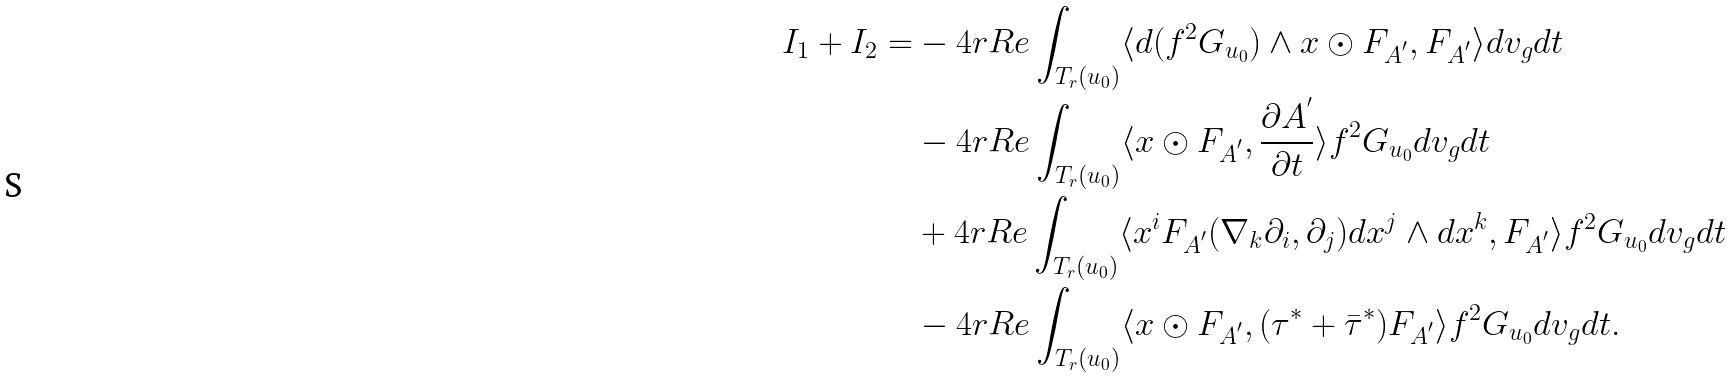<formula> <loc_0><loc_0><loc_500><loc_500>I _ { 1 } + I _ { 2 } = & - 4 r R e \int _ { T _ { r } ( u _ { 0 } ) } \langle d ( f ^ { 2 } G _ { u _ { 0 } } ) \wedge x \odot F _ { A ^ { ^ { \prime } } } , F _ { A ^ { ^ { \prime } } } \rangle d v _ { g } d t \\ & - 4 r R e \int _ { T _ { r } ( u _ { 0 } ) } \langle x \odot F _ { A ^ { ^ { \prime } } } , \frac { \partial A ^ { ^ { \prime } } } { \partial t } \rangle f ^ { 2 } G _ { u _ { 0 } } d v _ { g } d t \\ & + 4 r R e \int _ { T _ { r } ( u _ { 0 } ) } \langle x ^ { i } F _ { A ^ { ^ { \prime } } } ( \nabla _ { k } \partial _ { i } , \partial _ { j } ) d x ^ { j } \wedge d x ^ { k } , F _ { A ^ { ^ { \prime } } } \rangle f ^ { 2 } G _ { u _ { 0 } } d v _ { g } d t \\ & - 4 r R e \int _ { T _ { r } ( u _ { 0 } ) } \langle x \odot F _ { A ^ { ^ { \prime } } } , ( \tau ^ { * } + \bar { \tau } ^ { * } ) F _ { A ^ { ^ { \prime } } } \rangle f ^ { 2 } G _ { u _ { 0 } } d v _ { g } d t .</formula> 